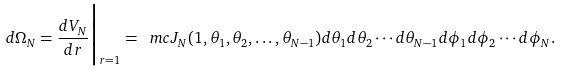<formula> <loc_0><loc_0><loc_500><loc_500>d \Omega _ { N } = \frac { d V _ { N } } { d r } \Big | _ { r = 1 } = \ m c J _ { N } ( 1 , \theta _ { 1 } , \theta _ { 2 } , \dots , \theta _ { N - 1 } ) d \theta _ { 1 } d \theta _ { 2 } \cdots d \theta _ { N - 1 } d \phi _ { 1 } d \phi _ { 2 } \cdots d \phi _ { N } .</formula> 